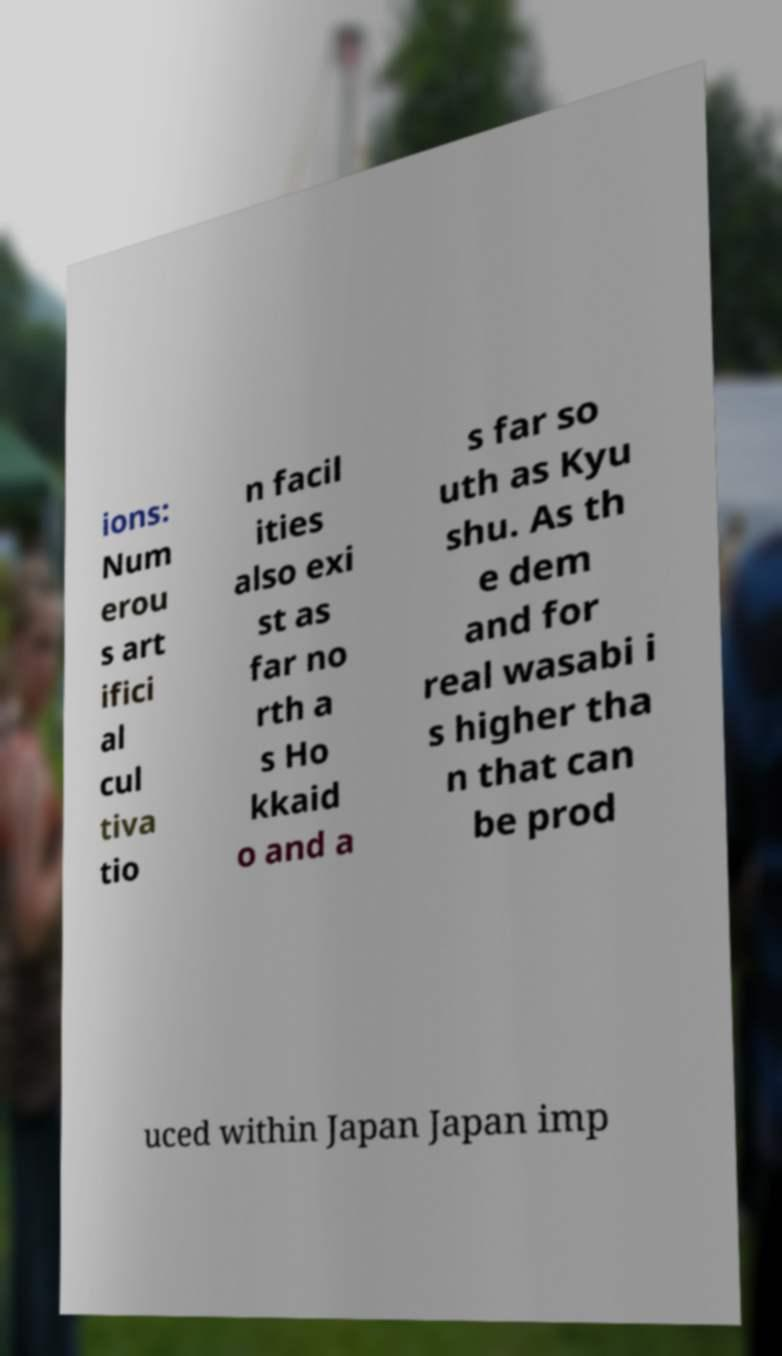Can you read and provide the text displayed in the image?This photo seems to have some interesting text. Can you extract and type it out for me? ions: Num erou s art ifici al cul tiva tio n facil ities also exi st as far no rth a s Ho kkaid o and a s far so uth as Kyu shu. As th e dem and for real wasabi i s higher tha n that can be prod uced within Japan Japan imp 